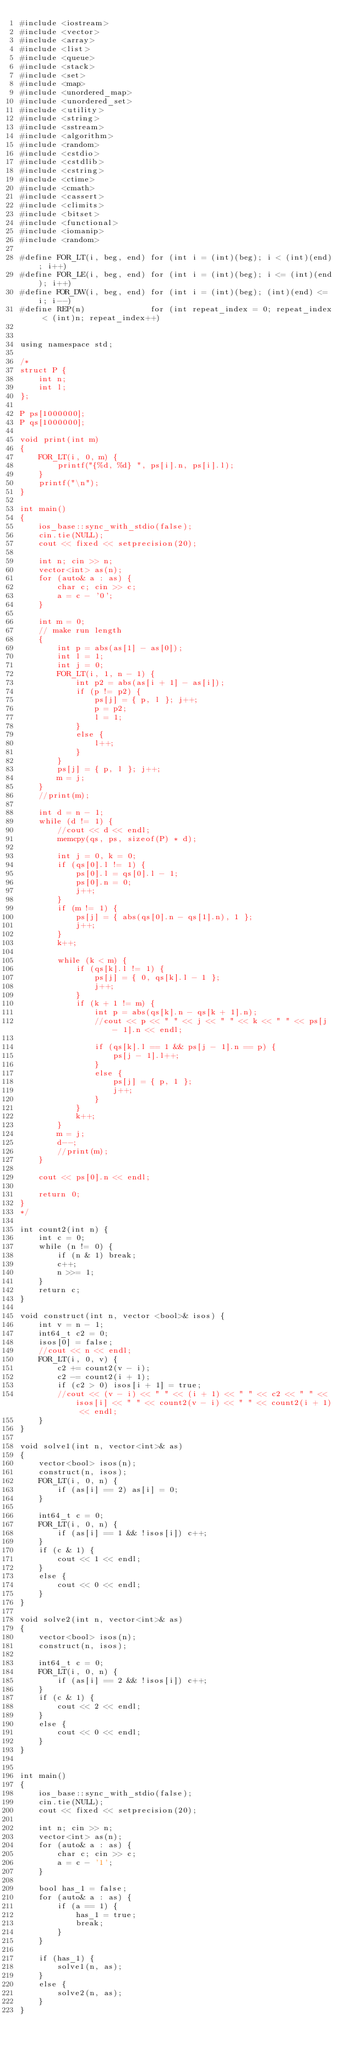<code> <loc_0><loc_0><loc_500><loc_500><_C++_>#include <iostream>
#include <vector>
#include <array>
#include <list>
#include <queue>
#include <stack>
#include <set>
#include <map>
#include <unordered_map>
#include <unordered_set>
#include <utility>
#include <string>
#include <sstream>
#include <algorithm>
#include <random>
#include <cstdio>
#include <cstdlib>
#include <cstring>
#include <ctime>
#include <cmath>
#include <cassert>
#include <climits>
#include <bitset>
#include <functional>
#include <iomanip>
#include <random>

#define FOR_LT(i, beg, end) for (int i = (int)(beg); i < (int)(end); i++)
#define FOR_LE(i, beg, end) for (int i = (int)(beg); i <= (int)(end); i++)
#define FOR_DW(i, beg, end) for (int i = (int)(beg); (int)(end) <= i; i--)
#define REP(n)              for (int repeat_index = 0; repeat_index < (int)n; repeat_index++)


using namespace std;

/*
struct P {
	int n;
	int l;
};

P ps[1000000];
P qs[1000000];

void print(int m)
{
	FOR_LT(i, 0, m) {
		printf("{%d, %d} ", ps[i].n, ps[i].l);
	}
	printf("\n");
}

int main()
{
	ios_base::sync_with_stdio(false);
	cin.tie(NULL);
	cout << fixed << setprecision(20);

	int n; cin >> n;
	vector<int> as(n);
	for (auto& a : as) {
		char c; cin >> c;
		a = c - '0';
	}

	int m = 0;
	// make run length
	{
		int p = abs(as[1] - as[0]);
		int l = 1;
		int j = 0;
		FOR_LT(i, 1, n - 1) {
			int p2 = abs(as[i + 1] - as[i]);
			if (p != p2) {
				ps[j] = { p, l }; j++;
				p = p2;
				l = 1;
			}
			else {
				l++;
			}
		}
		ps[j] = { p, l }; j++;
		m = j;
	}
	//print(m);

	int d = n - 1;
	while (d != 1) {
		//cout << d << endl;
		memcpy(qs, ps, sizeof(P) * d);

		int j = 0, k = 0;
		if (qs[0].l != 1) {
			ps[0].l = qs[0].l - 1;
			ps[0].n = 0;
			j++;
		}
		if (m != 1) {
			ps[j] = { abs(qs[0].n - qs[1].n), 1 };
			j++;
		}
		k++;

		while (k < m) {
			if (qs[k].l != 1) {
				ps[j] = { 0, qs[k].l - 1 };
				j++;
			}
			if (k + 1 != m) {
				int p = abs(qs[k].n - qs[k + 1].n);
				//cout << p << " " << j << " " << k << " " << ps[j - 1].n << endl;

				if (qs[k].l == 1 && ps[j - 1].n == p) {
					ps[j - 1].l++;
				}
				else {
					ps[j] = { p, 1 };
					j++;
				}
			}
			k++;
		}
		m = j;
		d--;
		//print(m);
	}

	cout << ps[0].n << endl;
	
	return 0;
}
*/

int count2(int n) {
	int c = 0;
	while (n != 0) {
		if (n & 1) break;
		c++;
		n >>= 1;
	}
	return c;
}

void construct(int n, vector <bool>& isos) {
	int v = n - 1;
	int64_t c2 = 0;
	isos[0] = false;
	//cout << n << endl;
	FOR_LT(i, 0, v) {
		c2 += count2(v - i);
		c2 -= count2(i + 1);
		if (c2 > 0) isos[i + 1] = true;
		//cout << (v - i) << " " << (i + 1) << " " << c2 << " " << isos[i] << " " << count2(v - i) << " " << count2(i + 1) << endl;
	}
}

void solve1(int n, vector<int>& as)
{
	vector<bool> isos(n);
	construct(n, isos);
	FOR_LT(i, 0, n) {
		if (as[i] == 2) as[i] = 0;
	}

	int64_t c = 0;
	FOR_LT(i, 0, n) {
		if (as[i] == 1 && !isos[i]) c++;
	}
	if (c & 1) {
		cout << 1 << endl;
	}
	else {
		cout << 0 << endl;
	}
}

void solve2(int n, vector<int>& as)
{
	vector<bool> isos(n);
	construct(n, isos);

	int64_t c = 0;
	FOR_LT(i, 0, n) {
		if (as[i] == 2 && !isos[i]) c++;
	}
	if (c & 1) {
		cout << 2 << endl;
	}
	else {
		cout << 0 << endl;
	}
}


int main()
{
	ios_base::sync_with_stdio(false);
	cin.tie(NULL);
	cout << fixed << setprecision(20);

	int n; cin >> n;
	vector<int> as(n);
	for (auto& a : as) {
		char c; cin >> c;
		a = c - '1';
	}

	bool has_1 = false;
	for (auto& a : as) {
		if (a == 1) {
			has_1 = true;
			break;
		}
	}

	if (has_1) {
		solve1(n, as);
	}
	else {
		solve2(n, as);
	}
}
</code> 